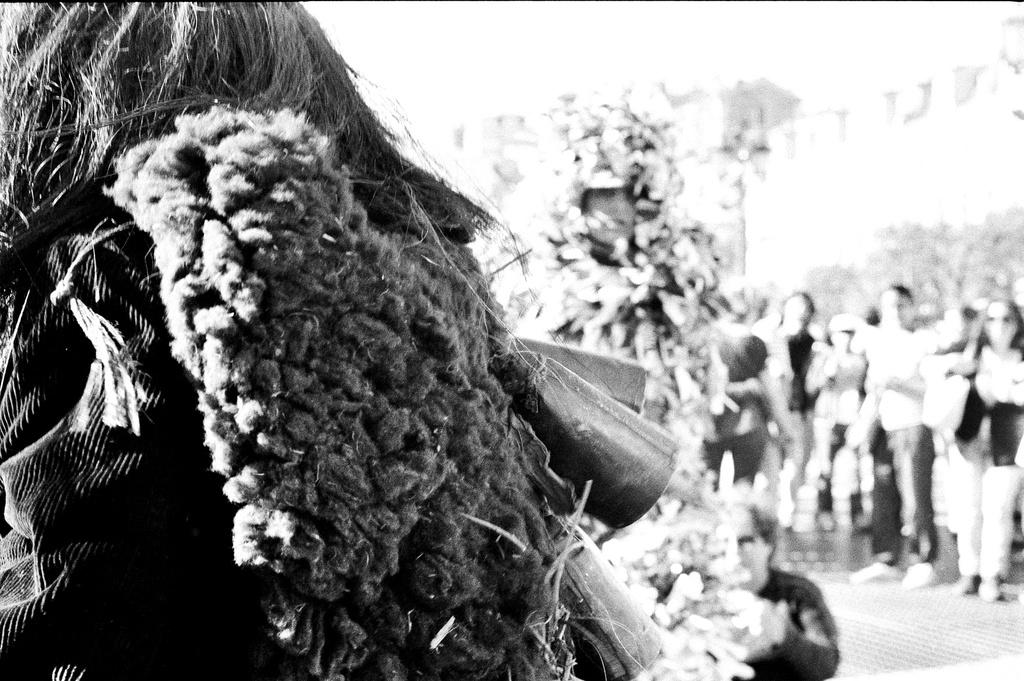How many persons can be seen in the image? There are persons in the image. What are the costumes of the two persons mentioned? Two of the persons are wearing different costumes. Can you describe the background of the image? The background of the image is blurred. What color mode is the image in? The image is in black and white mode. What type of grain is being served for lunch in the image? There is no grain or lunch depicted in the image; the focus is on the persons and their costumes. 